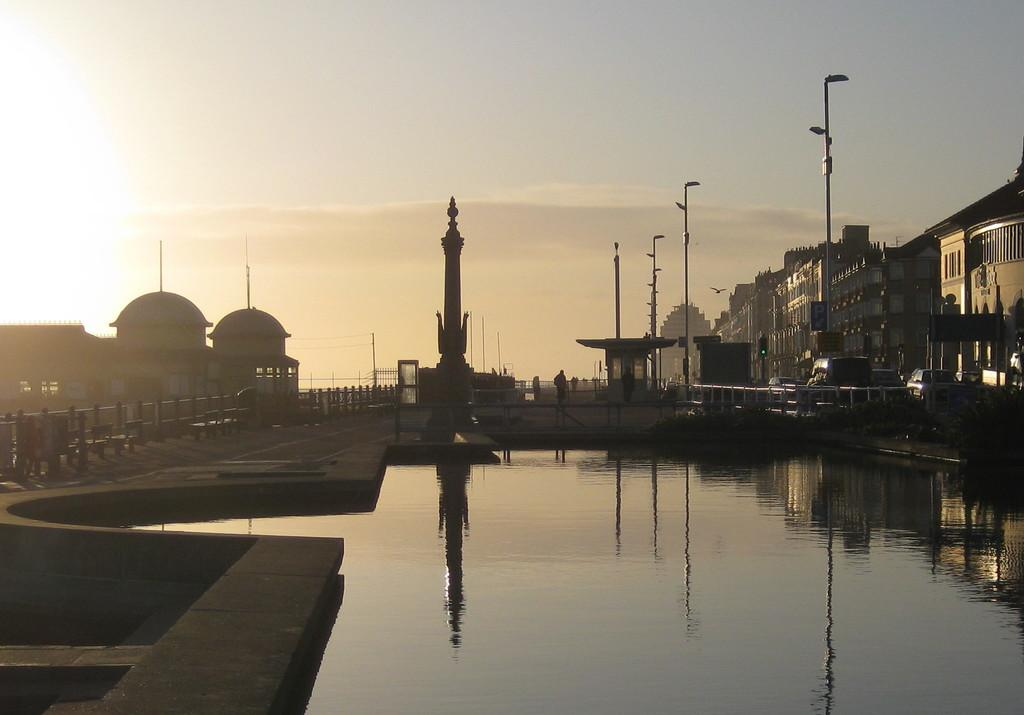What is the primary element visible in the image? There is water in the image. What type of structure can be seen in the image? There is a fence in the image. What can be seen in the background of the image? There are poles, vehicles, and buildings visible in the background of the image. How many ants can be seen crawling on the quiet part of the fence in the image? There are no ants visible in the image, and the fence is not described as quiet. 